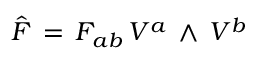<formula> <loc_0><loc_0><loc_500><loc_500>{ \hat { F } } \, = \, F _ { a b } \, V ^ { a } \, \wedge \, V ^ { b }</formula> 